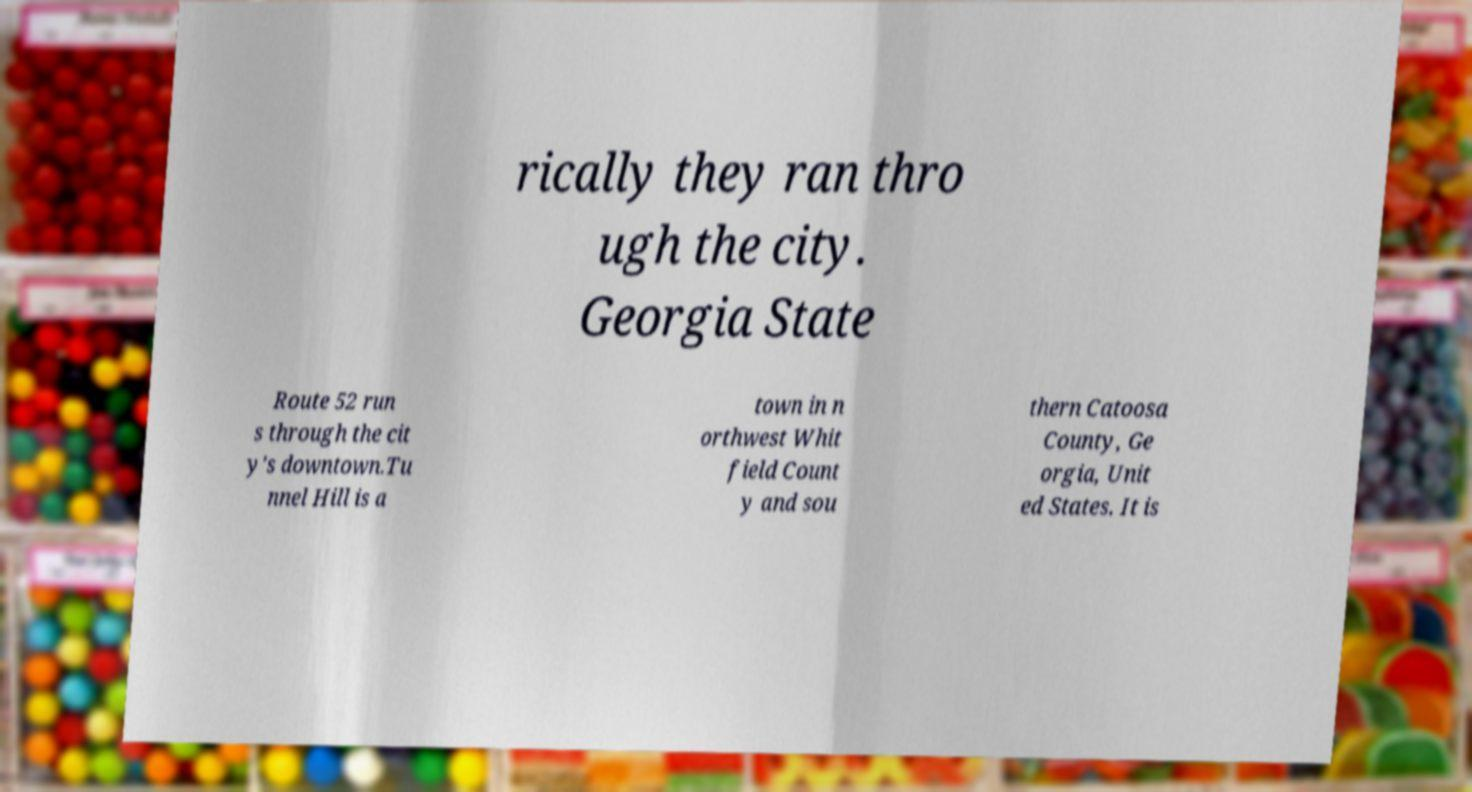Could you assist in decoding the text presented in this image and type it out clearly? rically they ran thro ugh the city. Georgia State Route 52 run s through the cit y's downtown.Tu nnel Hill is a town in n orthwest Whit field Count y and sou thern Catoosa County, Ge orgia, Unit ed States. It is 